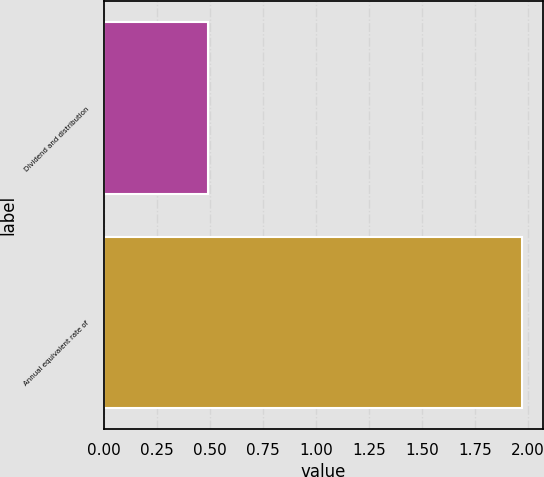Convert chart. <chart><loc_0><loc_0><loc_500><loc_500><bar_chart><fcel>Dividend and distribution<fcel>Annual equivalent rate of<nl><fcel>0.49<fcel>1.97<nl></chart> 